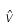<formula> <loc_0><loc_0><loc_500><loc_500>\hat { v }</formula> 